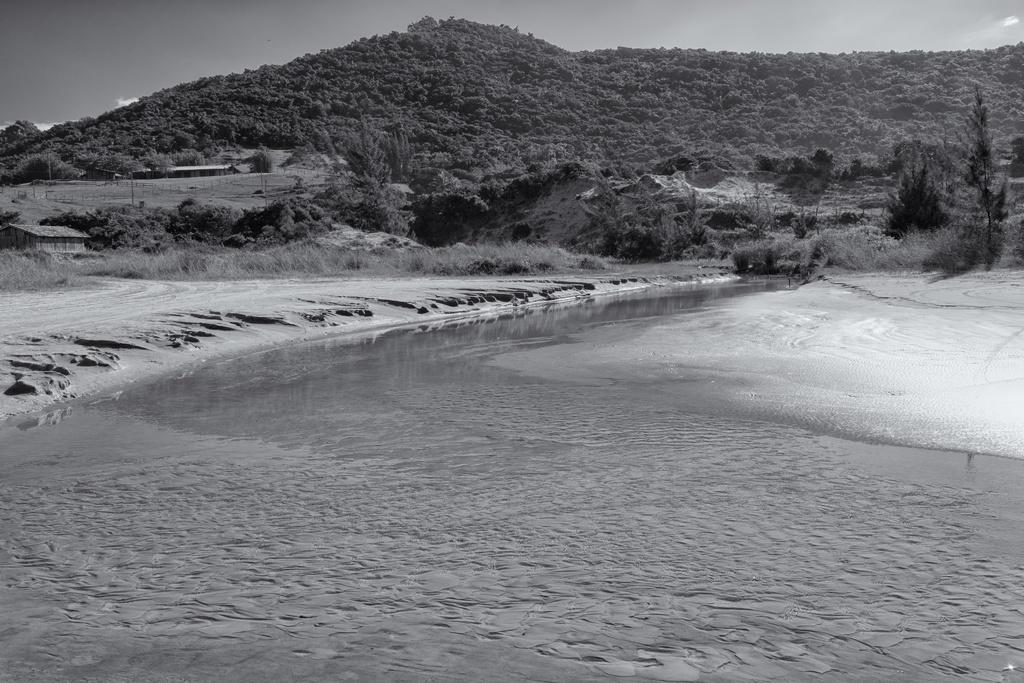What type of natural environment is depicted in the picture? There is an ocean in the picture, which indicates a coastal or beach setting. What can be found on the ground in the picture? There is sand on the floor in the picture. What is visible in the distance in the picture? There is a mountain in the backdrop of the picture. What is the condition of the mountain in the picture? The mountain is covered with trees. What is the condition of the sky in the picture? The sky is clear in the picture. How many children are playing with balls on the sand in the picture? There are no children or balls present in the picture; it features an ocean, sand, mountain, and trees. What type of goat can be seen climbing the mountain in the picture? There is no goat present in the picture; it features an ocean, sand, mountain, and trees. 